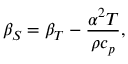<formula> <loc_0><loc_0><loc_500><loc_500>\beta _ { S } = \beta _ { T } - { \frac { \alpha ^ { 2 } T } { \rho c _ { p } } } ,</formula> 